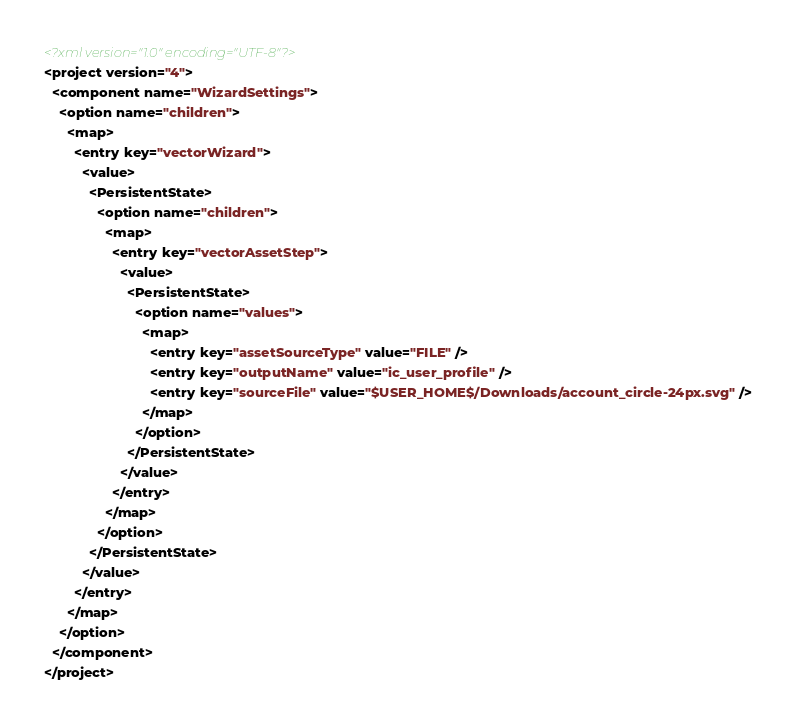Convert code to text. <code><loc_0><loc_0><loc_500><loc_500><_XML_><?xml version="1.0" encoding="UTF-8"?>
<project version="4">
  <component name="WizardSettings">
    <option name="children">
      <map>
        <entry key="vectorWizard">
          <value>
            <PersistentState>
              <option name="children">
                <map>
                  <entry key="vectorAssetStep">
                    <value>
                      <PersistentState>
                        <option name="values">
                          <map>
                            <entry key="assetSourceType" value="FILE" />
                            <entry key="outputName" value="ic_user_profile" />
                            <entry key="sourceFile" value="$USER_HOME$/Downloads/account_circle-24px.svg" />
                          </map>
                        </option>
                      </PersistentState>
                    </value>
                  </entry>
                </map>
              </option>
            </PersistentState>
          </value>
        </entry>
      </map>
    </option>
  </component>
</project></code> 